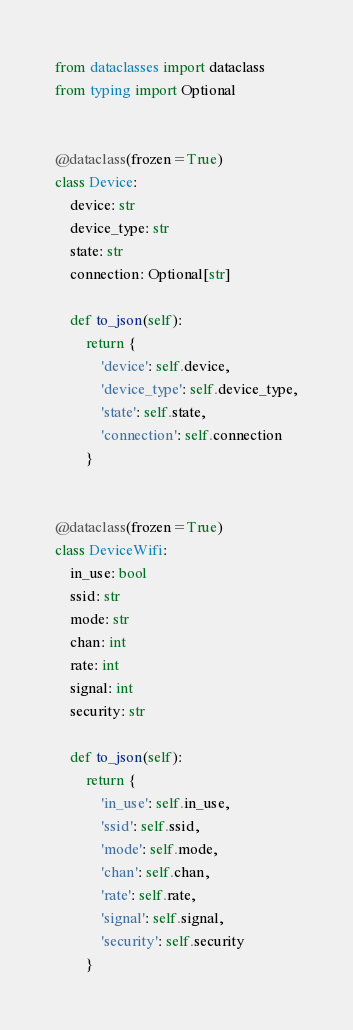Convert code to text. <code><loc_0><loc_0><loc_500><loc_500><_Python_>from dataclasses import dataclass
from typing import Optional


@dataclass(frozen=True)
class Device:
    device: str
    device_type: str
    state: str
    connection: Optional[str]

    def to_json(self):
        return {
            'device': self.device,
            'device_type': self.device_type,
            'state': self.state,
            'connection': self.connection
        }


@dataclass(frozen=True)
class DeviceWifi:
    in_use: bool
    ssid: str
    mode: str
    chan: int
    rate: int
    signal: int
    security: str

    def to_json(self):
        return {
            'in_use': self.in_use,
            'ssid': self.ssid,
            'mode': self.mode,
            'chan': self.chan,
            'rate': self.rate,
            'signal': self.signal,
            'security': self.security
        }
</code> 